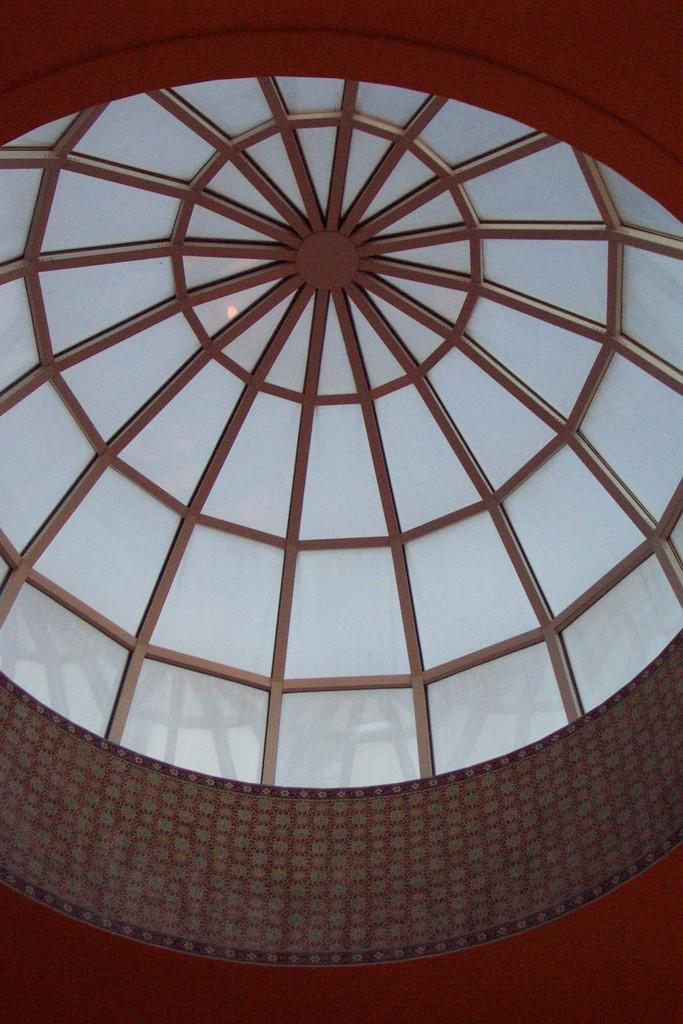What part of a building can be seen in the image? The image shows the ceiling of a building. What material is used for the ceiling in the image? The ceiling has glass panes. Is there a beggar asking for money in the image? No, there is no beggar present in the image. The image only shows the ceiling of a building with glass panes. 